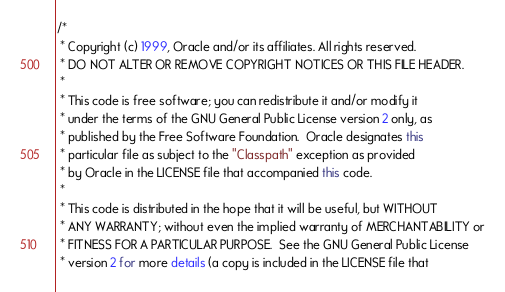Convert code to text. <code><loc_0><loc_0><loc_500><loc_500><_Java_>/*
 * Copyright (c) 1999, Oracle and/or its affiliates. All rights reserved.
 * DO NOT ALTER OR REMOVE COPYRIGHT NOTICES OR THIS FILE HEADER.
 *
 * This code is free software; you can redistribute it and/or modify it
 * under the terms of the GNU General Public License version 2 only, as
 * published by the Free Software Foundation.  Oracle designates this
 * particular file as subject to the "Classpath" exception as provided
 * by Oracle in the LICENSE file that accompanied this code.
 *
 * This code is distributed in the hope that it will be useful, but WITHOUT
 * ANY WARRANTY; without even the implied warranty of MERCHANTABILITY or
 * FITNESS FOR A PARTICULAR PURPOSE.  See the GNU General Public License
 * version 2 for more details (a copy is included in the LICENSE file that</code> 